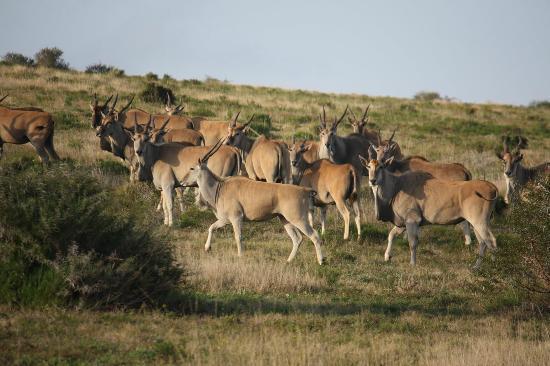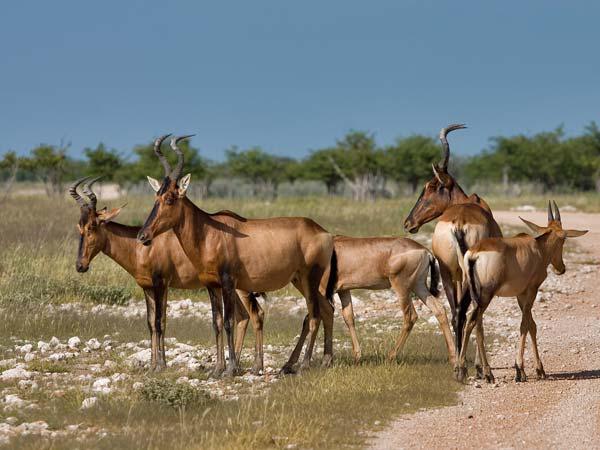The first image is the image on the left, the second image is the image on the right. Evaluate the accuracy of this statement regarding the images: "The left image shows brown antelope with another type of hooved mammal.". Is it true? Answer yes or no. No. 